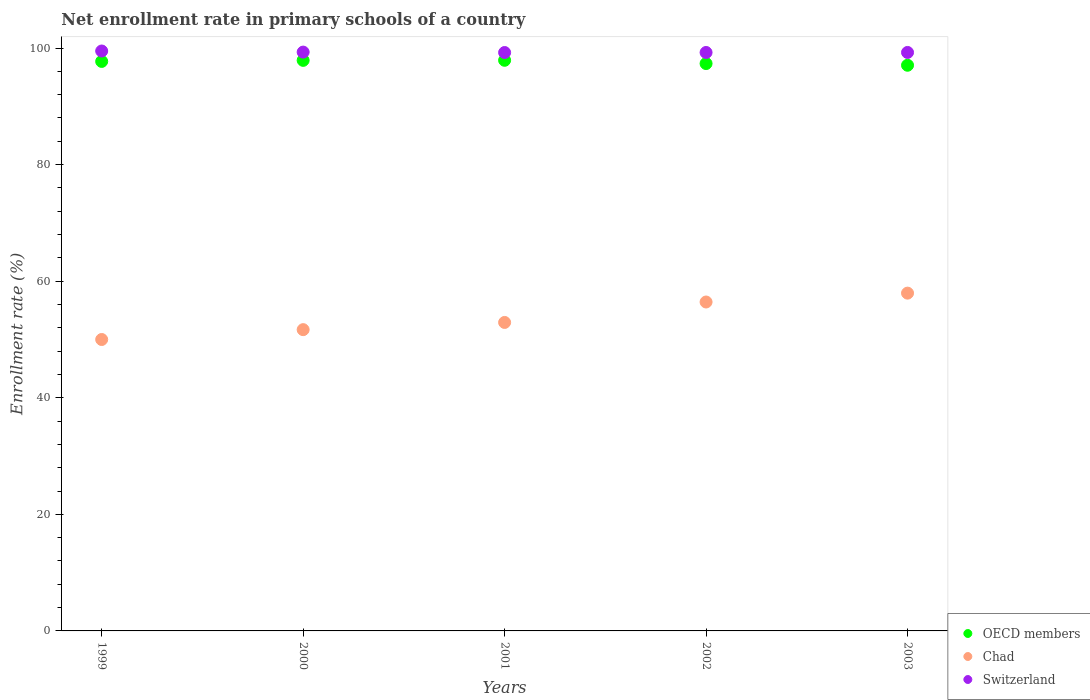What is the enrollment rate in primary schools in Switzerland in 1999?
Ensure brevity in your answer.  99.49. Across all years, what is the maximum enrollment rate in primary schools in Chad?
Your response must be concise. 57.95. Across all years, what is the minimum enrollment rate in primary schools in Switzerland?
Provide a short and direct response. 99.22. In which year was the enrollment rate in primary schools in Chad maximum?
Your answer should be compact. 2003. In which year was the enrollment rate in primary schools in Chad minimum?
Give a very brief answer. 1999. What is the total enrollment rate in primary schools in OECD members in the graph?
Ensure brevity in your answer.  487.84. What is the difference between the enrollment rate in primary schools in Switzerland in 2001 and that in 2002?
Offer a terse response. -0.01. What is the difference between the enrollment rate in primary schools in Chad in 2002 and the enrollment rate in primary schools in OECD members in 1999?
Make the answer very short. -41.27. What is the average enrollment rate in primary schools in OECD members per year?
Your answer should be compact. 97.57. In the year 2000, what is the difference between the enrollment rate in primary schools in Chad and enrollment rate in primary schools in OECD members?
Your answer should be very brief. -46.2. In how many years, is the enrollment rate in primary schools in Chad greater than 16 %?
Give a very brief answer. 5. What is the ratio of the enrollment rate in primary schools in Switzerland in 2000 to that in 2002?
Your response must be concise. 1. What is the difference between the highest and the second highest enrollment rate in primary schools in Switzerland?
Give a very brief answer. 0.19. What is the difference between the highest and the lowest enrollment rate in primary schools in OECD members?
Offer a terse response. 0.85. Is the sum of the enrollment rate in primary schools in Chad in 2001 and 2002 greater than the maximum enrollment rate in primary schools in Switzerland across all years?
Give a very brief answer. Yes. Is it the case that in every year, the sum of the enrollment rate in primary schools in Switzerland and enrollment rate in primary schools in Chad  is greater than the enrollment rate in primary schools in OECD members?
Offer a terse response. Yes. How many years are there in the graph?
Provide a succinct answer. 5. What is the difference between two consecutive major ticks on the Y-axis?
Ensure brevity in your answer.  20. Does the graph contain grids?
Give a very brief answer. No. How many legend labels are there?
Your response must be concise. 3. How are the legend labels stacked?
Provide a short and direct response. Vertical. What is the title of the graph?
Provide a succinct answer. Net enrollment rate in primary schools of a country. What is the label or title of the X-axis?
Keep it short and to the point. Years. What is the label or title of the Y-axis?
Your answer should be very brief. Enrollment rate (%). What is the Enrollment rate (%) in OECD members in 1999?
Offer a very short reply. 97.7. What is the Enrollment rate (%) in Chad in 1999?
Give a very brief answer. 49.99. What is the Enrollment rate (%) of Switzerland in 1999?
Offer a terse response. 99.49. What is the Enrollment rate (%) in OECD members in 2000?
Ensure brevity in your answer.  97.88. What is the Enrollment rate (%) of Chad in 2000?
Provide a succinct answer. 51.68. What is the Enrollment rate (%) in Switzerland in 2000?
Your response must be concise. 99.3. What is the Enrollment rate (%) in OECD members in 2001?
Give a very brief answer. 97.89. What is the Enrollment rate (%) in Chad in 2001?
Offer a very short reply. 52.92. What is the Enrollment rate (%) in Switzerland in 2001?
Your answer should be very brief. 99.22. What is the Enrollment rate (%) of OECD members in 2002?
Provide a short and direct response. 97.33. What is the Enrollment rate (%) of Chad in 2002?
Provide a short and direct response. 56.43. What is the Enrollment rate (%) in Switzerland in 2002?
Ensure brevity in your answer.  99.23. What is the Enrollment rate (%) of OECD members in 2003?
Offer a terse response. 97.04. What is the Enrollment rate (%) in Chad in 2003?
Your response must be concise. 57.95. What is the Enrollment rate (%) of Switzerland in 2003?
Provide a short and direct response. 99.24. Across all years, what is the maximum Enrollment rate (%) in OECD members?
Your answer should be very brief. 97.89. Across all years, what is the maximum Enrollment rate (%) of Chad?
Your answer should be compact. 57.95. Across all years, what is the maximum Enrollment rate (%) in Switzerland?
Offer a terse response. 99.49. Across all years, what is the minimum Enrollment rate (%) of OECD members?
Make the answer very short. 97.04. Across all years, what is the minimum Enrollment rate (%) in Chad?
Your answer should be very brief. 49.99. Across all years, what is the minimum Enrollment rate (%) in Switzerland?
Offer a terse response. 99.22. What is the total Enrollment rate (%) in OECD members in the graph?
Give a very brief answer. 487.84. What is the total Enrollment rate (%) of Chad in the graph?
Give a very brief answer. 268.97. What is the total Enrollment rate (%) of Switzerland in the graph?
Provide a short and direct response. 496.48. What is the difference between the Enrollment rate (%) of OECD members in 1999 and that in 2000?
Provide a short and direct response. -0.18. What is the difference between the Enrollment rate (%) of Chad in 1999 and that in 2000?
Offer a terse response. -1.69. What is the difference between the Enrollment rate (%) of Switzerland in 1999 and that in 2000?
Your answer should be very brief. 0.19. What is the difference between the Enrollment rate (%) in OECD members in 1999 and that in 2001?
Provide a short and direct response. -0.19. What is the difference between the Enrollment rate (%) of Chad in 1999 and that in 2001?
Give a very brief answer. -2.93. What is the difference between the Enrollment rate (%) of Switzerland in 1999 and that in 2001?
Ensure brevity in your answer.  0.26. What is the difference between the Enrollment rate (%) of OECD members in 1999 and that in 2002?
Offer a very short reply. 0.37. What is the difference between the Enrollment rate (%) in Chad in 1999 and that in 2002?
Give a very brief answer. -6.43. What is the difference between the Enrollment rate (%) in Switzerland in 1999 and that in 2002?
Give a very brief answer. 0.25. What is the difference between the Enrollment rate (%) in OECD members in 1999 and that in 2003?
Your answer should be compact. 0.66. What is the difference between the Enrollment rate (%) of Chad in 1999 and that in 2003?
Provide a succinct answer. -7.95. What is the difference between the Enrollment rate (%) in Switzerland in 1999 and that in 2003?
Provide a short and direct response. 0.25. What is the difference between the Enrollment rate (%) in OECD members in 2000 and that in 2001?
Offer a terse response. -0.01. What is the difference between the Enrollment rate (%) in Chad in 2000 and that in 2001?
Your response must be concise. -1.24. What is the difference between the Enrollment rate (%) in Switzerland in 2000 and that in 2001?
Your response must be concise. 0.07. What is the difference between the Enrollment rate (%) in OECD members in 2000 and that in 2002?
Offer a terse response. 0.55. What is the difference between the Enrollment rate (%) in Chad in 2000 and that in 2002?
Your response must be concise. -4.74. What is the difference between the Enrollment rate (%) of Switzerland in 2000 and that in 2002?
Offer a very short reply. 0.07. What is the difference between the Enrollment rate (%) of OECD members in 2000 and that in 2003?
Keep it short and to the point. 0.84. What is the difference between the Enrollment rate (%) of Chad in 2000 and that in 2003?
Provide a short and direct response. -6.26. What is the difference between the Enrollment rate (%) of Switzerland in 2000 and that in 2003?
Your response must be concise. 0.06. What is the difference between the Enrollment rate (%) of OECD members in 2001 and that in 2002?
Offer a very short reply. 0.56. What is the difference between the Enrollment rate (%) of Chad in 2001 and that in 2002?
Give a very brief answer. -3.51. What is the difference between the Enrollment rate (%) of Switzerland in 2001 and that in 2002?
Keep it short and to the point. -0.01. What is the difference between the Enrollment rate (%) in OECD members in 2001 and that in 2003?
Provide a short and direct response. 0.85. What is the difference between the Enrollment rate (%) in Chad in 2001 and that in 2003?
Provide a succinct answer. -5.03. What is the difference between the Enrollment rate (%) of Switzerland in 2001 and that in 2003?
Provide a short and direct response. -0.01. What is the difference between the Enrollment rate (%) in OECD members in 2002 and that in 2003?
Keep it short and to the point. 0.29. What is the difference between the Enrollment rate (%) in Chad in 2002 and that in 2003?
Make the answer very short. -1.52. What is the difference between the Enrollment rate (%) in Switzerland in 2002 and that in 2003?
Keep it short and to the point. -0.01. What is the difference between the Enrollment rate (%) in OECD members in 1999 and the Enrollment rate (%) in Chad in 2000?
Provide a succinct answer. 46.02. What is the difference between the Enrollment rate (%) in OECD members in 1999 and the Enrollment rate (%) in Switzerland in 2000?
Your response must be concise. -1.6. What is the difference between the Enrollment rate (%) in Chad in 1999 and the Enrollment rate (%) in Switzerland in 2000?
Your answer should be very brief. -49.3. What is the difference between the Enrollment rate (%) in OECD members in 1999 and the Enrollment rate (%) in Chad in 2001?
Keep it short and to the point. 44.78. What is the difference between the Enrollment rate (%) of OECD members in 1999 and the Enrollment rate (%) of Switzerland in 2001?
Provide a short and direct response. -1.53. What is the difference between the Enrollment rate (%) in Chad in 1999 and the Enrollment rate (%) in Switzerland in 2001?
Ensure brevity in your answer.  -49.23. What is the difference between the Enrollment rate (%) of OECD members in 1999 and the Enrollment rate (%) of Chad in 2002?
Provide a short and direct response. 41.27. What is the difference between the Enrollment rate (%) in OECD members in 1999 and the Enrollment rate (%) in Switzerland in 2002?
Your answer should be compact. -1.53. What is the difference between the Enrollment rate (%) in Chad in 1999 and the Enrollment rate (%) in Switzerland in 2002?
Provide a short and direct response. -49.24. What is the difference between the Enrollment rate (%) in OECD members in 1999 and the Enrollment rate (%) in Chad in 2003?
Make the answer very short. 39.75. What is the difference between the Enrollment rate (%) in OECD members in 1999 and the Enrollment rate (%) in Switzerland in 2003?
Provide a short and direct response. -1.54. What is the difference between the Enrollment rate (%) of Chad in 1999 and the Enrollment rate (%) of Switzerland in 2003?
Provide a short and direct response. -49.25. What is the difference between the Enrollment rate (%) of OECD members in 2000 and the Enrollment rate (%) of Chad in 2001?
Offer a very short reply. 44.96. What is the difference between the Enrollment rate (%) of OECD members in 2000 and the Enrollment rate (%) of Switzerland in 2001?
Ensure brevity in your answer.  -1.34. What is the difference between the Enrollment rate (%) of Chad in 2000 and the Enrollment rate (%) of Switzerland in 2001?
Give a very brief answer. -47.54. What is the difference between the Enrollment rate (%) of OECD members in 2000 and the Enrollment rate (%) of Chad in 2002?
Your answer should be very brief. 41.45. What is the difference between the Enrollment rate (%) of OECD members in 2000 and the Enrollment rate (%) of Switzerland in 2002?
Provide a short and direct response. -1.35. What is the difference between the Enrollment rate (%) in Chad in 2000 and the Enrollment rate (%) in Switzerland in 2002?
Your answer should be very brief. -47.55. What is the difference between the Enrollment rate (%) in OECD members in 2000 and the Enrollment rate (%) in Chad in 2003?
Provide a succinct answer. 39.93. What is the difference between the Enrollment rate (%) of OECD members in 2000 and the Enrollment rate (%) of Switzerland in 2003?
Offer a very short reply. -1.36. What is the difference between the Enrollment rate (%) in Chad in 2000 and the Enrollment rate (%) in Switzerland in 2003?
Your response must be concise. -47.56. What is the difference between the Enrollment rate (%) of OECD members in 2001 and the Enrollment rate (%) of Chad in 2002?
Provide a succinct answer. 41.46. What is the difference between the Enrollment rate (%) in OECD members in 2001 and the Enrollment rate (%) in Switzerland in 2002?
Offer a very short reply. -1.34. What is the difference between the Enrollment rate (%) in Chad in 2001 and the Enrollment rate (%) in Switzerland in 2002?
Keep it short and to the point. -46.31. What is the difference between the Enrollment rate (%) of OECD members in 2001 and the Enrollment rate (%) of Chad in 2003?
Give a very brief answer. 39.94. What is the difference between the Enrollment rate (%) of OECD members in 2001 and the Enrollment rate (%) of Switzerland in 2003?
Provide a succinct answer. -1.35. What is the difference between the Enrollment rate (%) in Chad in 2001 and the Enrollment rate (%) in Switzerland in 2003?
Make the answer very short. -46.32. What is the difference between the Enrollment rate (%) of OECD members in 2002 and the Enrollment rate (%) of Chad in 2003?
Your answer should be very brief. 39.39. What is the difference between the Enrollment rate (%) of OECD members in 2002 and the Enrollment rate (%) of Switzerland in 2003?
Provide a short and direct response. -1.91. What is the difference between the Enrollment rate (%) in Chad in 2002 and the Enrollment rate (%) in Switzerland in 2003?
Give a very brief answer. -42.81. What is the average Enrollment rate (%) in OECD members per year?
Make the answer very short. 97.57. What is the average Enrollment rate (%) in Chad per year?
Provide a short and direct response. 53.79. What is the average Enrollment rate (%) of Switzerland per year?
Offer a very short reply. 99.3. In the year 1999, what is the difference between the Enrollment rate (%) in OECD members and Enrollment rate (%) in Chad?
Make the answer very short. 47.71. In the year 1999, what is the difference between the Enrollment rate (%) of OECD members and Enrollment rate (%) of Switzerland?
Keep it short and to the point. -1.79. In the year 1999, what is the difference between the Enrollment rate (%) in Chad and Enrollment rate (%) in Switzerland?
Your response must be concise. -49.49. In the year 2000, what is the difference between the Enrollment rate (%) of OECD members and Enrollment rate (%) of Chad?
Provide a succinct answer. 46.2. In the year 2000, what is the difference between the Enrollment rate (%) in OECD members and Enrollment rate (%) in Switzerland?
Your answer should be compact. -1.42. In the year 2000, what is the difference between the Enrollment rate (%) of Chad and Enrollment rate (%) of Switzerland?
Offer a terse response. -47.61. In the year 2001, what is the difference between the Enrollment rate (%) of OECD members and Enrollment rate (%) of Chad?
Provide a succinct answer. 44.97. In the year 2001, what is the difference between the Enrollment rate (%) of OECD members and Enrollment rate (%) of Switzerland?
Make the answer very short. -1.33. In the year 2001, what is the difference between the Enrollment rate (%) in Chad and Enrollment rate (%) in Switzerland?
Provide a succinct answer. -46.3. In the year 2002, what is the difference between the Enrollment rate (%) in OECD members and Enrollment rate (%) in Chad?
Offer a terse response. 40.91. In the year 2002, what is the difference between the Enrollment rate (%) in OECD members and Enrollment rate (%) in Switzerland?
Give a very brief answer. -1.9. In the year 2002, what is the difference between the Enrollment rate (%) of Chad and Enrollment rate (%) of Switzerland?
Your answer should be compact. -42.81. In the year 2003, what is the difference between the Enrollment rate (%) of OECD members and Enrollment rate (%) of Chad?
Offer a very short reply. 39.09. In the year 2003, what is the difference between the Enrollment rate (%) of OECD members and Enrollment rate (%) of Switzerland?
Your answer should be very brief. -2.2. In the year 2003, what is the difference between the Enrollment rate (%) of Chad and Enrollment rate (%) of Switzerland?
Offer a very short reply. -41.29. What is the ratio of the Enrollment rate (%) in OECD members in 1999 to that in 2000?
Offer a terse response. 1. What is the ratio of the Enrollment rate (%) in Chad in 1999 to that in 2000?
Ensure brevity in your answer.  0.97. What is the ratio of the Enrollment rate (%) in OECD members in 1999 to that in 2001?
Make the answer very short. 1. What is the ratio of the Enrollment rate (%) in Chad in 1999 to that in 2001?
Provide a short and direct response. 0.94. What is the ratio of the Enrollment rate (%) in Switzerland in 1999 to that in 2001?
Ensure brevity in your answer.  1. What is the ratio of the Enrollment rate (%) of Chad in 1999 to that in 2002?
Your response must be concise. 0.89. What is the ratio of the Enrollment rate (%) of Switzerland in 1999 to that in 2002?
Your answer should be very brief. 1. What is the ratio of the Enrollment rate (%) in OECD members in 1999 to that in 2003?
Your answer should be compact. 1.01. What is the ratio of the Enrollment rate (%) of Chad in 1999 to that in 2003?
Offer a very short reply. 0.86. What is the ratio of the Enrollment rate (%) of Chad in 2000 to that in 2001?
Your answer should be very brief. 0.98. What is the ratio of the Enrollment rate (%) in Switzerland in 2000 to that in 2001?
Give a very brief answer. 1. What is the ratio of the Enrollment rate (%) in OECD members in 2000 to that in 2002?
Offer a very short reply. 1.01. What is the ratio of the Enrollment rate (%) of Chad in 2000 to that in 2002?
Your response must be concise. 0.92. What is the ratio of the Enrollment rate (%) of Switzerland in 2000 to that in 2002?
Your response must be concise. 1. What is the ratio of the Enrollment rate (%) in OECD members in 2000 to that in 2003?
Ensure brevity in your answer.  1.01. What is the ratio of the Enrollment rate (%) of Chad in 2000 to that in 2003?
Keep it short and to the point. 0.89. What is the ratio of the Enrollment rate (%) of OECD members in 2001 to that in 2002?
Keep it short and to the point. 1.01. What is the ratio of the Enrollment rate (%) in Chad in 2001 to that in 2002?
Make the answer very short. 0.94. What is the ratio of the Enrollment rate (%) of Switzerland in 2001 to that in 2002?
Keep it short and to the point. 1. What is the ratio of the Enrollment rate (%) in OECD members in 2001 to that in 2003?
Provide a succinct answer. 1.01. What is the ratio of the Enrollment rate (%) in Chad in 2001 to that in 2003?
Provide a short and direct response. 0.91. What is the ratio of the Enrollment rate (%) of Chad in 2002 to that in 2003?
Provide a succinct answer. 0.97. What is the difference between the highest and the second highest Enrollment rate (%) of OECD members?
Your answer should be compact. 0.01. What is the difference between the highest and the second highest Enrollment rate (%) of Chad?
Give a very brief answer. 1.52. What is the difference between the highest and the second highest Enrollment rate (%) of Switzerland?
Your response must be concise. 0.19. What is the difference between the highest and the lowest Enrollment rate (%) of OECD members?
Provide a short and direct response. 0.85. What is the difference between the highest and the lowest Enrollment rate (%) in Chad?
Make the answer very short. 7.95. What is the difference between the highest and the lowest Enrollment rate (%) in Switzerland?
Make the answer very short. 0.26. 